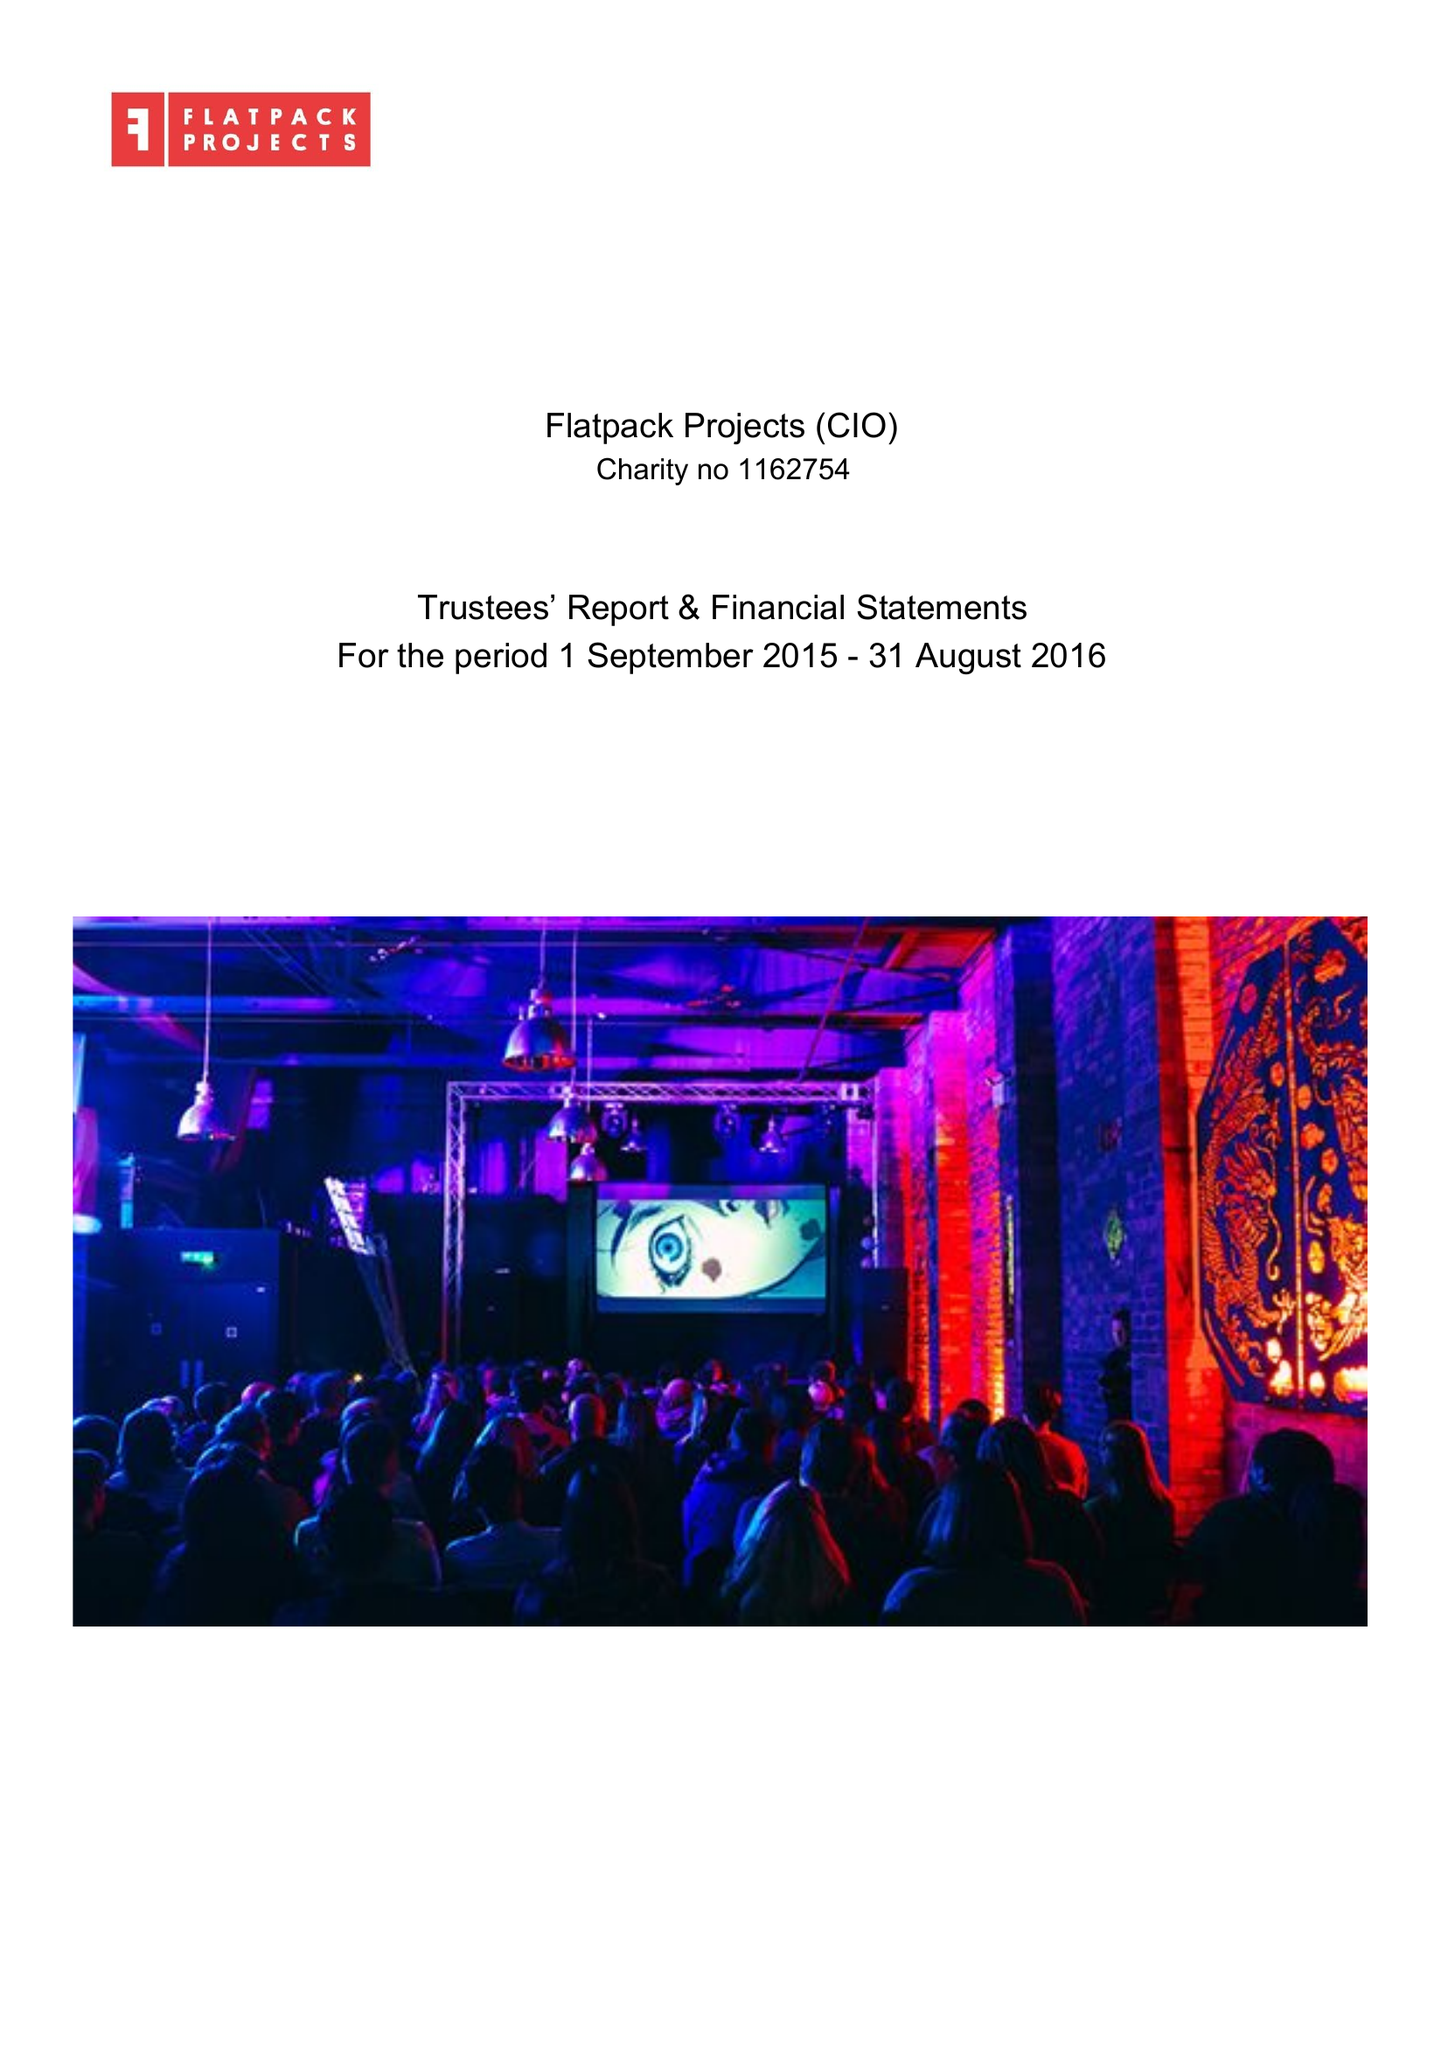What is the value for the charity_number?
Answer the question using a single word or phrase. 1162754 